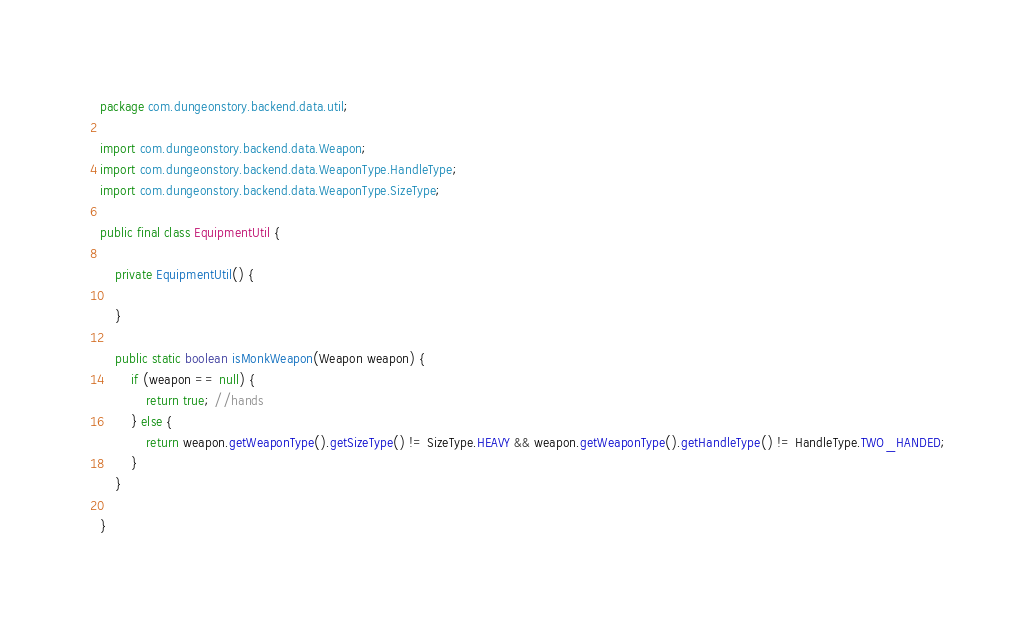<code> <loc_0><loc_0><loc_500><loc_500><_Java_>package com.dungeonstory.backend.data.util;

import com.dungeonstory.backend.data.Weapon;
import com.dungeonstory.backend.data.WeaponType.HandleType;
import com.dungeonstory.backend.data.WeaponType.SizeType;

public final class EquipmentUtil {

    private EquipmentUtil() {

    }

    public static boolean isMonkWeapon(Weapon weapon) {
        if (weapon == null) {
            return true; //hands
        } else {
            return weapon.getWeaponType().getSizeType() != SizeType.HEAVY && weapon.getWeaponType().getHandleType() != HandleType.TWO_HANDED;
        }
    }

}
</code> 